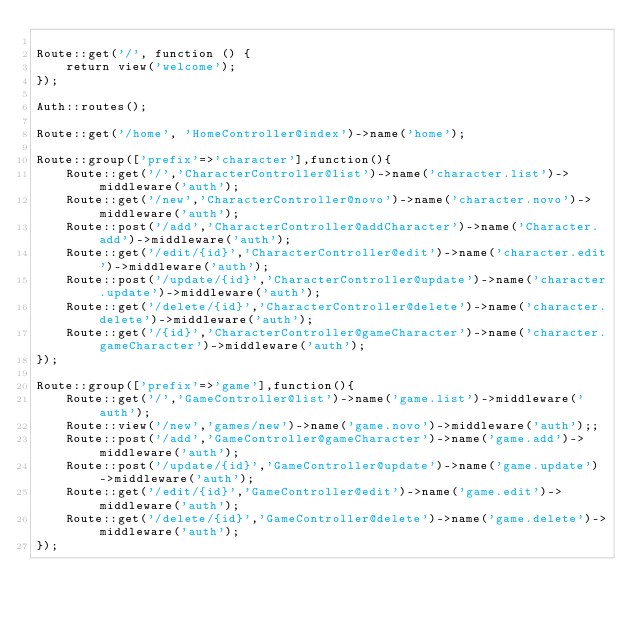<code> <loc_0><loc_0><loc_500><loc_500><_PHP_>
Route::get('/', function () {
    return view('welcome');
});

Auth::routes();

Route::get('/home', 'HomeController@index')->name('home');

Route::group(['prefix'=>'character'],function(){
    Route::get('/','CharacterController@list')->name('character.list')->middleware('auth');
    Route::get('/new','CharacterController@novo')->name('character.novo')->middleware('auth');
    Route::post('/add','CharacterController@addCharacter')->name('Character.add')->middleware('auth');
    Route::get('/edit/{id}','CharacterController@edit')->name('character.edit')->middleware('auth');
    Route::post('/update/{id}','CharacterController@update')->name('character.update')->middleware('auth');
    Route::get('/delete/{id}','CharacterController@delete')->name('character.delete')->middleware('auth');
    Route::get('/{id}','CharacterController@gameCharacter')->name('character.gameCharacter')->middleware('auth');
});

Route::group(['prefix'=>'game'],function(){
    Route::get('/','GameController@list')->name('game.list')->middleware('auth');
    Route::view('/new','games/new')->name('game.novo')->middleware('auth');;
    Route::post('/add','GameController@gameCharacter')->name('game.add')->middleware('auth');
    Route::post('/update/{id}','GameController@update')->name('game.update')->middleware('auth');
    Route::get('/edit/{id}','GameController@edit')->name('game.edit')->middleware('auth');
    Route::get('/delete/{id}','GameController@delete')->name('game.delete')->middleware('auth');
});

</code> 